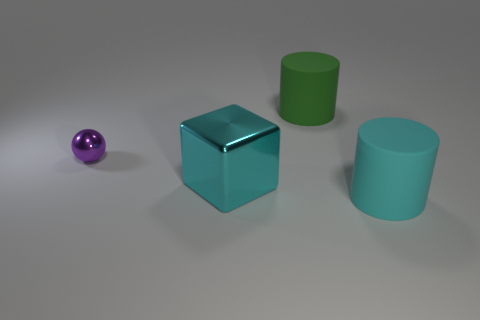Add 1 big blue metallic blocks. How many objects exist? 5 Subtract all balls. How many objects are left? 3 Add 4 large green metal cylinders. How many large green metal cylinders exist? 4 Subtract 0 brown cylinders. How many objects are left? 4 Subtract all small metal objects. Subtract all purple balls. How many objects are left? 2 Add 1 tiny purple metallic spheres. How many tiny purple metallic spheres are left? 2 